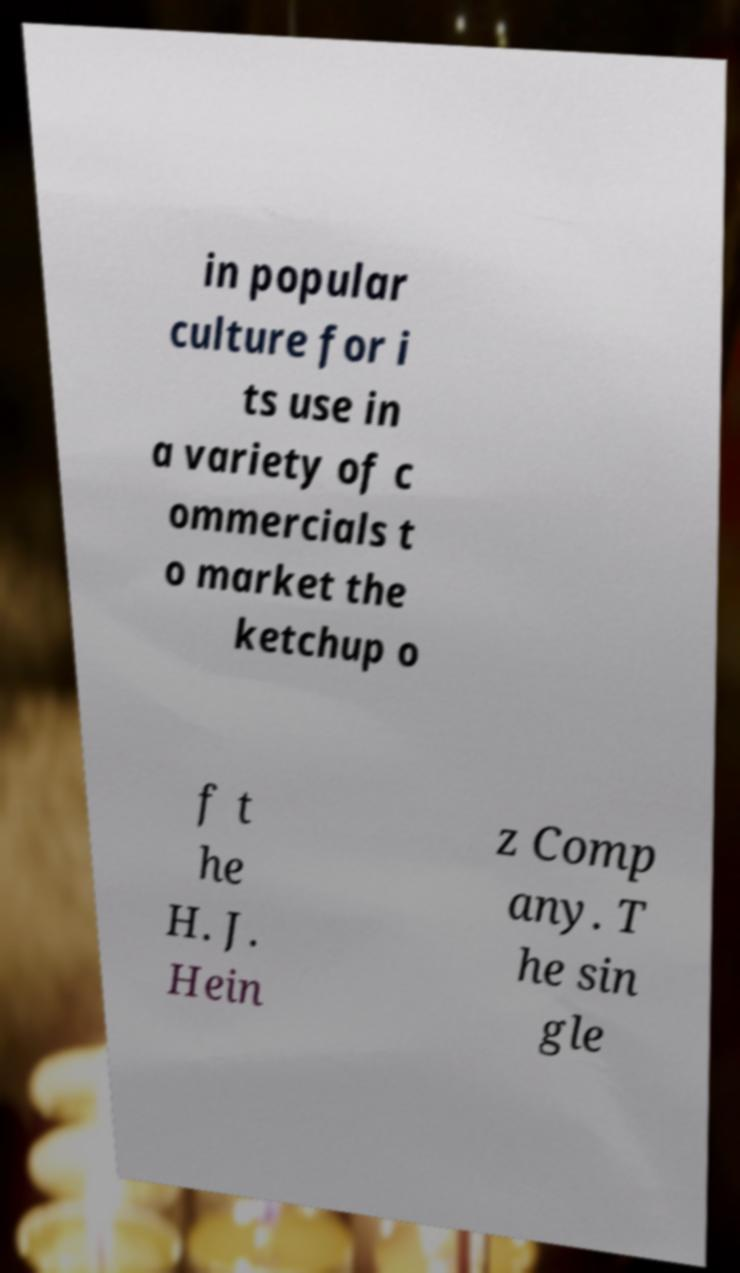Please read and relay the text visible in this image. What does it say? in popular culture for i ts use in a variety of c ommercials t o market the ketchup o f t he H. J. Hein z Comp any. T he sin gle 